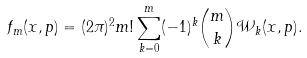<formula> <loc_0><loc_0><loc_500><loc_500>f _ { m } ( x , p ) = ( 2 \pi ) ^ { 2 } m ! \sum _ { k = 0 } ^ { m } ( - 1 ) ^ { k } { m \choose k } \mathcal { W } _ { k } ( x , p ) .</formula> 